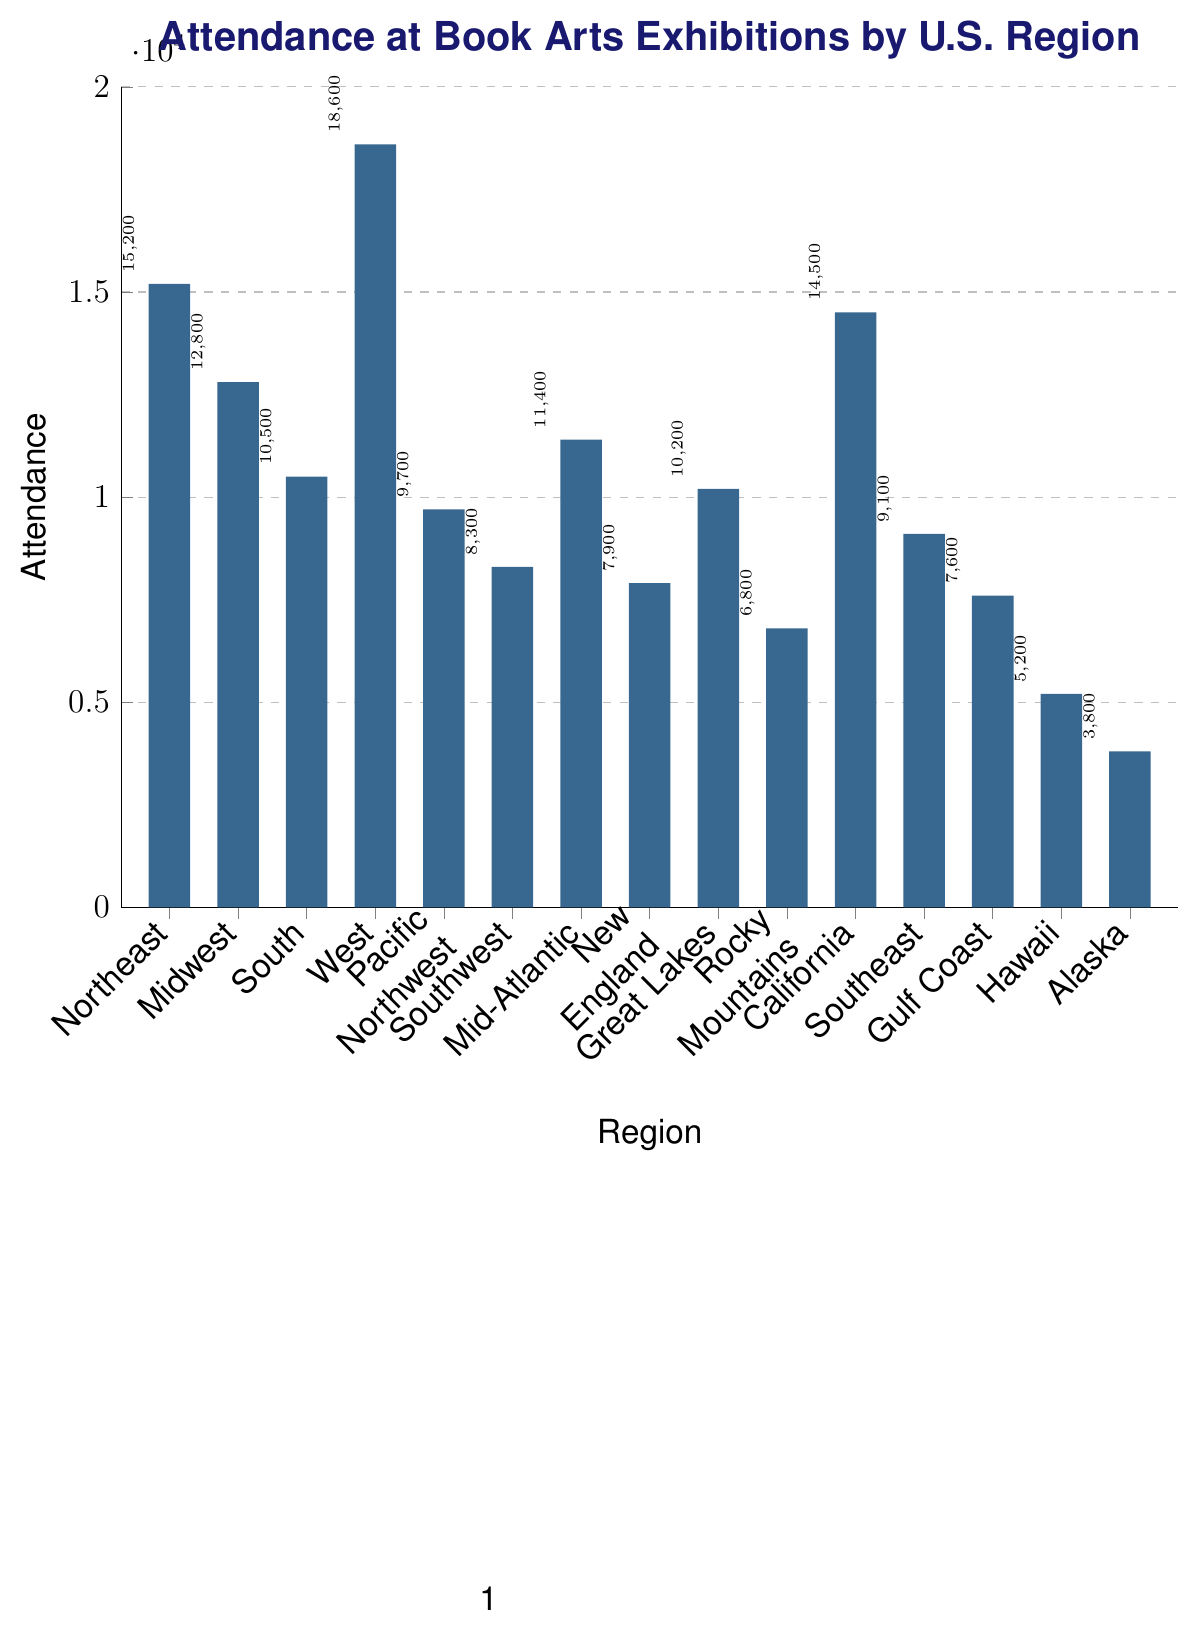what region has the highest attendance? The region with the highest bar in the chart represents the highest attendance number. The West has the highest bar, indicating an attendance of 18600.
Answer: West which region has the lowest attendance? The region with the shortest bar in the chart reflects the lowest attendance number. Alaska has the shortest bar, indicating an attendance of 3800.
Answer: Alaska how does the attendance in the Northeast compare to the Midwest? To determine this, compare the heights of the bars for the Northeast and the Midwest. The Northeast has an attendance of 15200, which is higher than the Midwest's 12800.
Answer: Northeast has higher attendance what is the difference in attendance between the Southeast and Southwest regions? The attendance for Southeast is 9100 and for Southwest is 8300. Calculate the difference by subtracting the Southwest's attendance from the Southeast's attendance: 9100 - 8300 = 800.
Answer: 800 which regions have attendance numbers greater than 10000? Identify bars with heights greater than the 10000 mark. These regions are Northeast (15200), Midwest (12800), West (18600), Mid-Atlantic (11400), California (14500), and Great Lakes (10200).
Answer: Northeast, Midwest, West, Mid-Atlantic, California, Great Lakes how many regions have attendance numbers below 10000? Count the bars whose heights are below the 10000 mark. These are Pacific Northwest, Southwest, New England, Rocky Mountains, Southeast, Gulf Coast, Hawaii, and Alaska, totaling 8 regions.
Answer: 8 what is the total attendance for the Northeast, Midwest, and South regions combined? Add the attendance numbers for these three regions: Northeast (15200) + Midwest (12800) + South (10500) = 38500.
Answer: 38500 what is the average attendance across all regions? Sum all attendance values and divide by the number of regions. Total attendance is 15200 + 12800 + 10500 + 18600 + 9700 + 8300 + 11400 + 7900 + 10200 + 6800 + 14500 + 9100 + 7600 + 5200 + 3800 = 140600. There are 15 regions, so 140600 / 15 ≈ 9373.33.
Answer: 9373.33 which regions have nearly equal attendance? Look for bars with approximately the same height. The Southeast (9100) and Pacific Northwest (9700) have similar attendance figures, considering a small difference.
Answer: Pacific Northwest, Southeast 